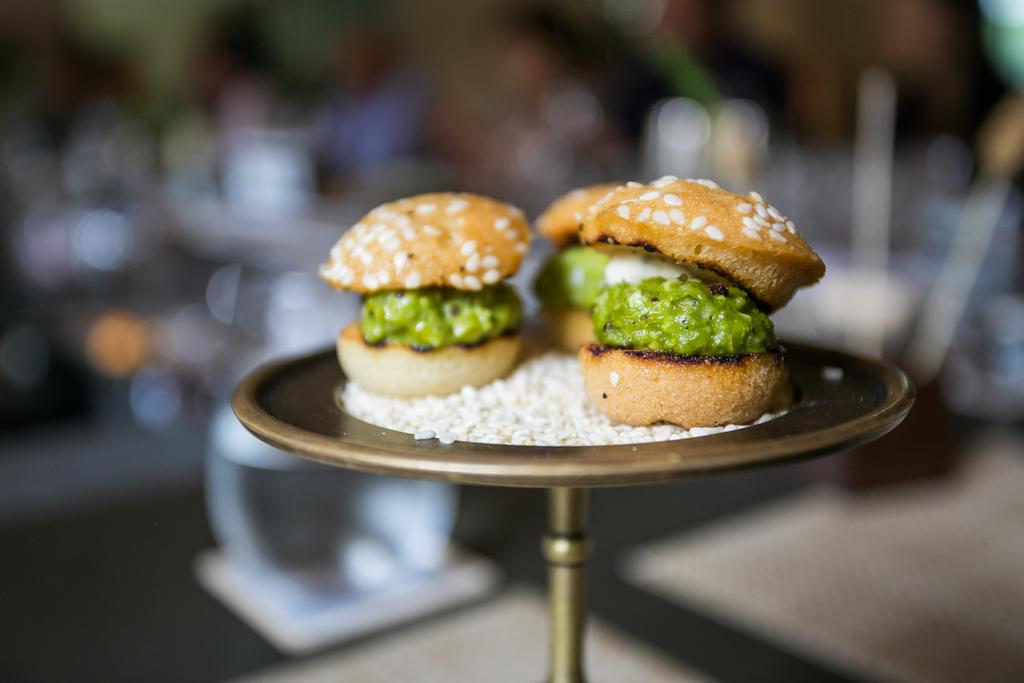What is the main subject of the image? There is food on a stand in the center of the image. What can be seen at the bottom of the image? The floor is visible at the bottom of the image. How would you describe the background of the image? The background of the image is blurry. What type of parcel is being taught how to play chess in the image? There is no parcel or chess game present in the image. 